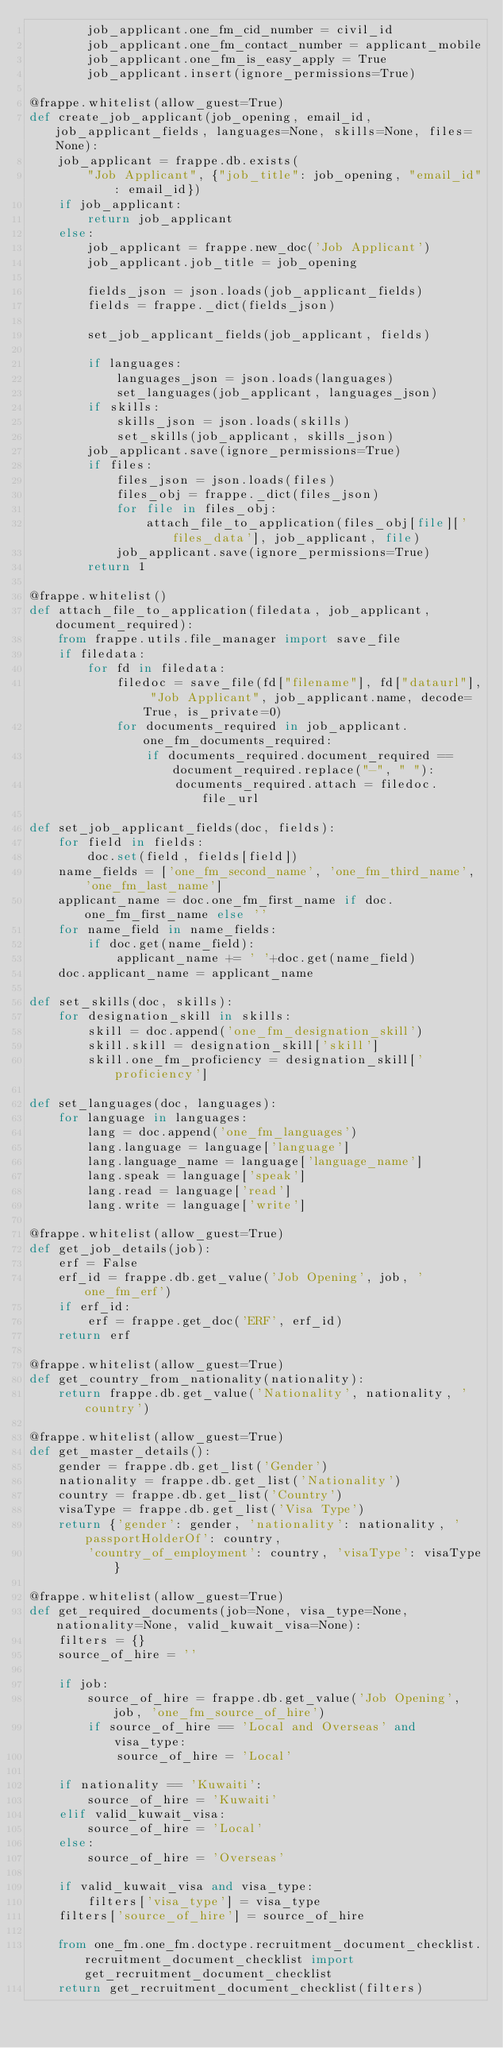Convert code to text. <code><loc_0><loc_0><loc_500><loc_500><_Python_>        job_applicant.one_fm_cid_number = civil_id
        job_applicant.one_fm_contact_number = applicant_mobile
        job_applicant.one_fm_is_easy_apply = True
        job_applicant.insert(ignore_permissions=True)

@frappe.whitelist(allow_guest=True)
def create_job_applicant(job_opening, email_id, job_applicant_fields, languages=None, skills=None, files=None):
    job_applicant = frappe.db.exists(
        "Job Applicant", {"job_title": job_opening, "email_id": email_id})
    if job_applicant:
        return job_applicant
    else:
        job_applicant = frappe.new_doc('Job Applicant')
        job_applicant.job_title = job_opening

        fields_json = json.loads(job_applicant_fields)
        fields = frappe._dict(fields_json)

        set_job_applicant_fields(job_applicant, fields)

        if languages:
            languages_json = json.loads(languages)
            set_languages(job_applicant, languages_json)
        if skills:
            skills_json = json.loads(skills)
            set_skills(job_applicant, skills_json)
        job_applicant.save(ignore_permissions=True)
        if files:
            files_json = json.loads(files)
            files_obj = frappe._dict(files_json)
            for file in files_obj:
                attach_file_to_application(files_obj[file]['files_data'], job_applicant, file)
            job_applicant.save(ignore_permissions=True)
        return 1

@frappe.whitelist()
def attach_file_to_application(filedata, job_applicant, document_required):
    from frappe.utils.file_manager import save_file
    if filedata:
        for fd in filedata:
            filedoc = save_file(fd["filename"], fd["dataurl"], "Job Applicant", job_applicant.name, decode=True, is_private=0)
            for documents_required in job_applicant.one_fm_documents_required:
                if documents_required.document_required == document_required.replace("-", " "):
                    documents_required.attach = filedoc.file_url

def set_job_applicant_fields(doc, fields):
    for field in fields:
        doc.set(field, fields[field])
    name_fields = ['one_fm_second_name', 'one_fm_third_name', 'one_fm_last_name']
    applicant_name = doc.one_fm_first_name if doc.one_fm_first_name else ''
    for name_field in name_fields:
        if doc.get(name_field):
            applicant_name += ' '+doc.get(name_field)
    doc.applicant_name = applicant_name

def set_skills(doc, skills):
    for designation_skill in skills:
        skill = doc.append('one_fm_designation_skill')
        skill.skill = designation_skill['skill']
        skill.one_fm_proficiency = designation_skill['proficiency']

def set_languages(doc, languages):
    for language in languages:
        lang = doc.append('one_fm_languages')
        lang.language = language['language']
        lang.language_name = language['language_name']
        lang.speak = language['speak']
        lang.read = language['read']
        lang.write = language['write']

@frappe.whitelist(allow_guest=True)
def get_job_details(job):
    erf = False
    erf_id = frappe.db.get_value('Job Opening', job, 'one_fm_erf')
    if erf_id:
        erf = frappe.get_doc('ERF', erf_id)
    return erf

@frappe.whitelist(allow_guest=True)
def get_country_from_nationality(nationality):
    return frappe.db.get_value('Nationality', nationality, 'country')

@frappe.whitelist(allow_guest=True)
def get_master_details():
    gender = frappe.db.get_list('Gender')
    nationality = frappe.db.get_list('Nationality')
    country = frappe.db.get_list('Country')
    visaType = frappe.db.get_list('Visa Type')
    return {'gender': gender, 'nationality': nationality, 'passportHolderOf': country,
        'country_of_employment': country, 'visaType': visaType}

@frappe.whitelist(allow_guest=True)
def get_required_documents(job=None, visa_type=None, nationality=None, valid_kuwait_visa=None):
    filters = {}
    source_of_hire = ''

    if job:
        source_of_hire = frappe.db.get_value('Job Opening', job, 'one_fm_source_of_hire')
        if source_of_hire == 'Local and Overseas' and visa_type:
            source_of_hire = 'Local'

    if nationality == 'Kuwaiti':
        source_of_hire = 'Kuwaiti'
    elif valid_kuwait_visa:
        source_of_hire = 'Local'
    else:
        source_of_hire = 'Overseas'

    if valid_kuwait_visa and visa_type:
        filters['visa_type'] = visa_type
    filters['source_of_hire'] = source_of_hire

    from one_fm.one_fm.doctype.recruitment_document_checklist.recruitment_document_checklist import get_recruitment_document_checklist
    return get_recruitment_document_checklist(filters)
</code> 